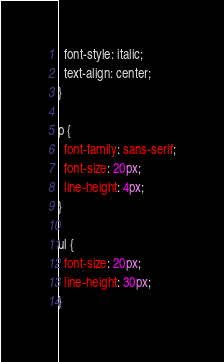Convert code to text. <code><loc_0><loc_0><loc_500><loc_500><_CSS_>  font-style: italic;
  text-align: center;
}

p {
  font-family: sans-serif;
  font-size: 20px;
  line-height: 4px;
}

ul {
  font-size: 20px;
  line-height: 30px;
}
</code> 